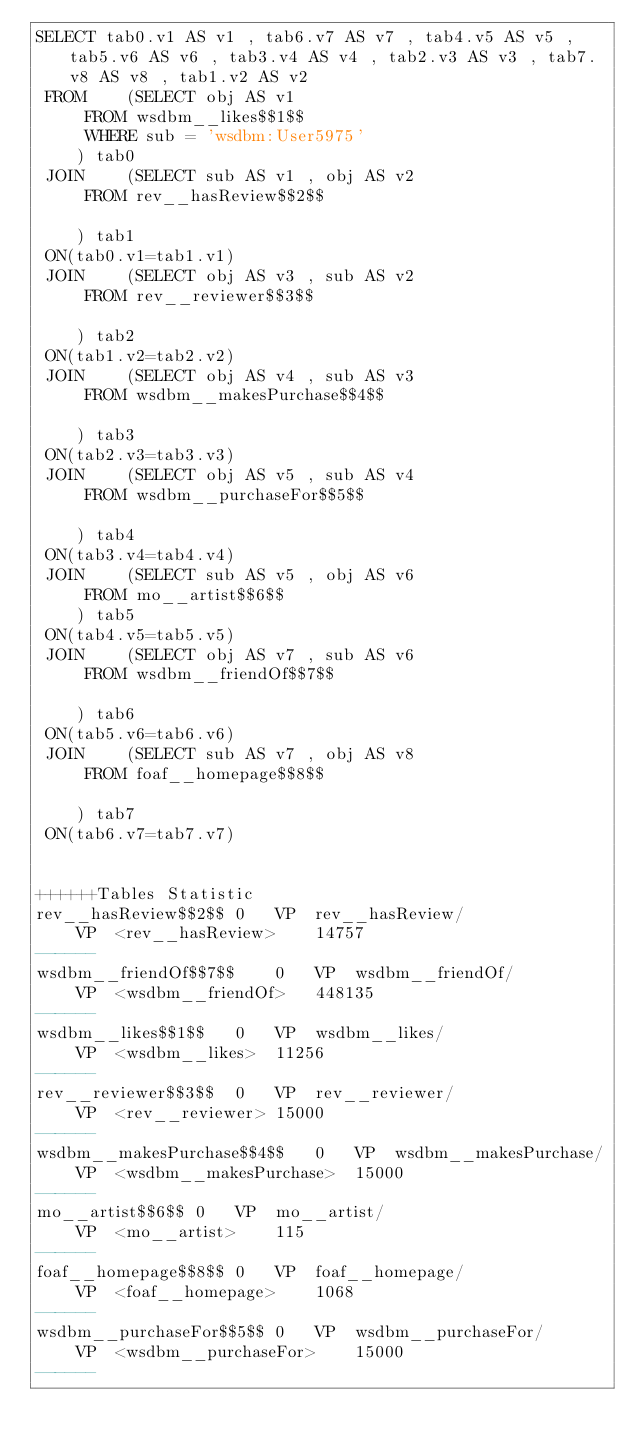<code> <loc_0><loc_0><loc_500><loc_500><_SQL_>SELECT tab0.v1 AS v1 , tab6.v7 AS v7 , tab4.v5 AS v5 , tab5.v6 AS v6 , tab3.v4 AS v4 , tab2.v3 AS v3 , tab7.v8 AS v8 , tab1.v2 AS v2 
 FROM    (SELECT obj AS v1 
	 FROM wsdbm__likes$$1$$ 
	 WHERE sub = 'wsdbm:User5975'
	) tab0
 JOIN    (SELECT sub AS v1 , obj AS v2 
	 FROM rev__hasReview$$2$$
	
	) tab1
 ON(tab0.v1=tab1.v1)
 JOIN    (SELECT obj AS v3 , sub AS v2 
	 FROM rev__reviewer$$3$$
	
	) tab2
 ON(tab1.v2=tab2.v2)
 JOIN    (SELECT obj AS v4 , sub AS v3 
	 FROM wsdbm__makesPurchase$$4$$
	
	) tab3
 ON(tab2.v3=tab3.v3)
 JOIN    (SELECT obj AS v5 , sub AS v4 
	 FROM wsdbm__purchaseFor$$5$$
	
	) tab4
 ON(tab3.v4=tab4.v4)
 JOIN    (SELECT sub AS v5 , obj AS v6 
	 FROM mo__artist$$6$$
	) tab5
 ON(tab4.v5=tab5.v5)
 JOIN    (SELECT obj AS v7 , sub AS v6 
	 FROM wsdbm__friendOf$$7$$
	
	) tab6
 ON(tab5.v6=tab6.v6)
 JOIN    (SELECT sub AS v7 , obj AS v8 
	 FROM foaf__homepage$$8$$
	
	) tab7
 ON(tab6.v7=tab7.v7)


++++++Tables Statistic
rev__hasReview$$2$$	0	VP	rev__hasReview/
	VP	<rev__hasReview>	14757
------
wsdbm__friendOf$$7$$	0	VP	wsdbm__friendOf/
	VP	<wsdbm__friendOf>	448135
------
wsdbm__likes$$1$$	0	VP	wsdbm__likes/
	VP	<wsdbm__likes>	11256
------
rev__reviewer$$3$$	0	VP	rev__reviewer/
	VP	<rev__reviewer>	15000
------
wsdbm__makesPurchase$$4$$	0	VP	wsdbm__makesPurchase/
	VP	<wsdbm__makesPurchase>	15000
------
mo__artist$$6$$	0	VP	mo__artist/
	VP	<mo__artist>	115
------
foaf__homepage$$8$$	0	VP	foaf__homepage/
	VP	<foaf__homepage>	1068
------
wsdbm__purchaseFor$$5$$	0	VP	wsdbm__purchaseFor/
	VP	<wsdbm__purchaseFor>	15000
------
</code> 